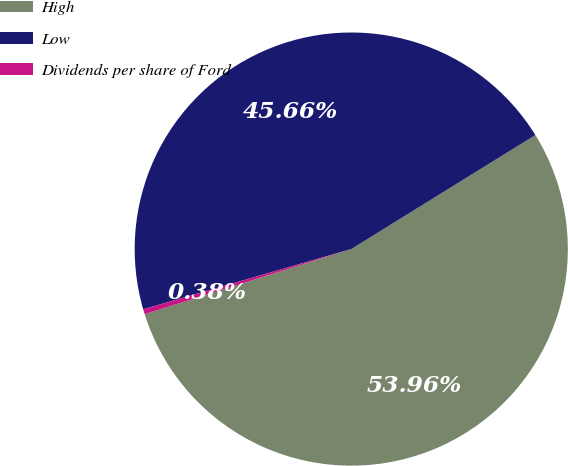<chart> <loc_0><loc_0><loc_500><loc_500><pie_chart><fcel>High<fcel>Low<fcel>Dividends per share of Ford<nl><fcel>53.96%<fcel>45.66%<fcel>0.38%<nl></chart> 